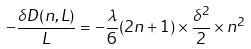Convert formula to latex. <formula><loc_0><loc_0><loc_500><loc_500>- \frac { \delta D ( n , L ) } { L } = - \frac { \lambda } { 6 } ( 2 n + 1 ) \times \frac { \delta ^ { 2 } } { 2 } \times n ^ { 2 }</formula> 